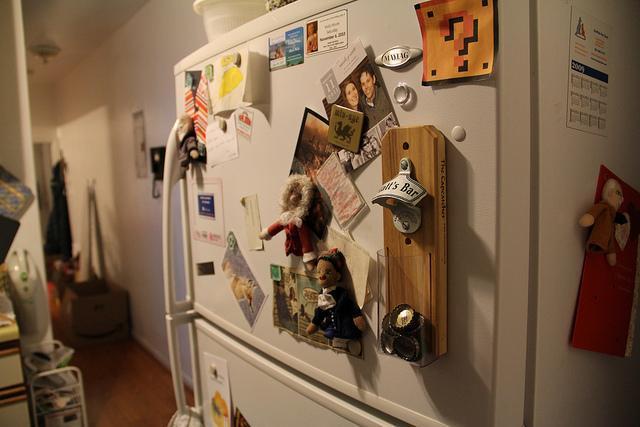How many women wearing a red dress complimented by black stockings are there?
Give a very brief answer. 0. 